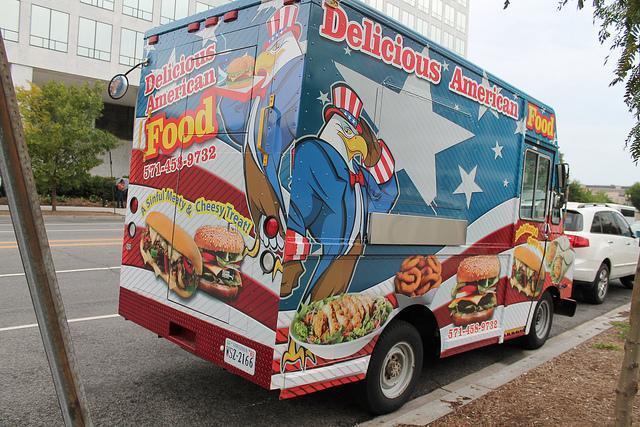Is the statement "The bowl is on the truck." accurate regarding the image?
Answer yes or no. Yes. 